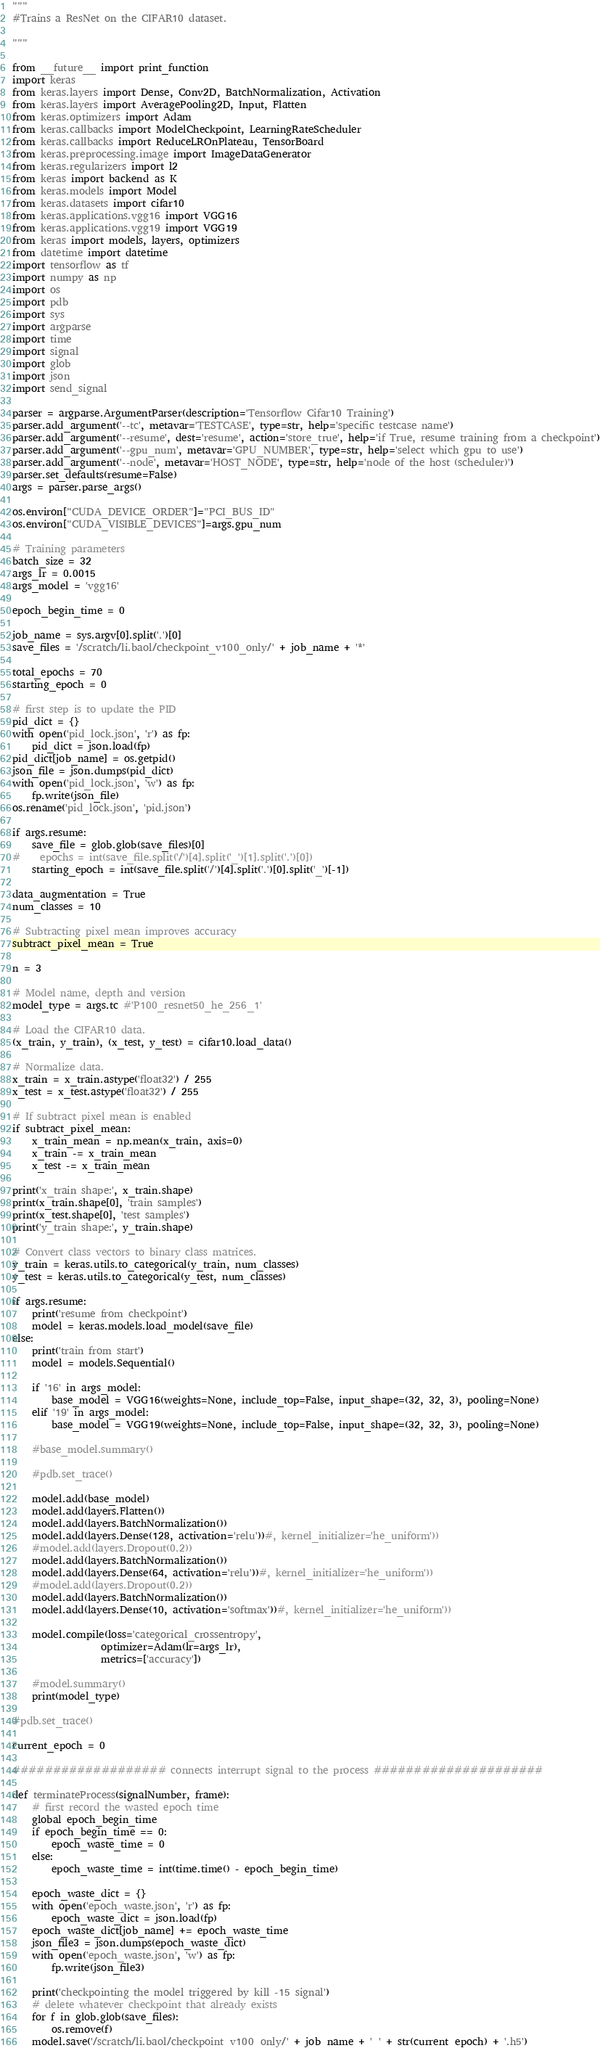<code> <loc_0><loc_0><loc_500><loc_500><_Python_>"""
#Trains a ResNet on the CIFAR10 dataset.

"""

from __future__ import print_function
import keras
from keras.layers import Dense, Conv2D, BatchNormalization, Activation
from keras.layers import AveragePooling2D, Input, Flatten
from keras.optimizers import Adam
from keras.callbacks import ModelCheckpoint, LearningRateScheduler
from keras.callbacks import ReduceLROnPlateau, TensorBoard
from keras.preprocessing.image import ImageDataGenerator
from keras.regularizers import l2
from keras import backend as K
from keras.models import Model
from keras.datasets import cifar10
from keras.applications.vgg16 import VGG16
from keras.applications.vgg19 import VGG19
from keras import models, layers, optimizers
from datetime import datetime
import tensorflow as tf
import numpy as np
import os
import pdb
import sys
import argparse
import time
import signal
import glob
import json
import send_signal

parser = argparse.ArgumentParser(description='Tensorflow Cifar10 Training')
parser.add_argument('--tc', metavar='TESTCASE', type=str, help='specific testcase name')
parser.add_argument('--resume', dest='resume', action='store_true', help='if True, resume training from a checkpoint')
parser.add_argument('--gpu_num', metavar='GPU_NUMBER', type=str, help='select which gpu to use')
parser.add_argument('--node', metavar='HOST_NODE', type=str, help='node of the host (scheduler)')
parser.set_defaults(resume=False)
args = parser.parse_args()

os.environ["CUDA_DEVICE_ORDER"]="PCI_BUS_ID"
os.environ["CUDA_VISIBLE_DEVICES"]=args.gpu_num

# Training parameters
batch_size = 32
args_lr = 0.0015
args_model = 'vgg16'

epoch_begin_time = 0

job_name = sys.argv[0].split('.')[0]
save_files = '/scratch/li.baol/checkpoint_v100_only/' + job_name + '*'

total_epochs = 70
starting_epoch = 0

# first step is to update the PID
pid_dict = {}
with open('pid_lock.json', 'r') as fp:
    pid_dict = json.load(fp)
pid_dict[job_name] = os.getpid()
json_file = json.dumps(pid_dict)
with open('pid_lock.json', 'w') as fp:
    fp.write(json_file) 
os.rename('pid_lock.json', 'pid.json')

if args.resume:
    save_file = glob.glob(save_files)[0]
#    epochs = int(save_file.split('/')[4].split('_')[1].split('.')[0])
    starting_epoch = int(save_file.split('/')[4].split('.')[0].split('_')[-1])

data_augmentation = True
num_classes = 10

# Subtracting pixel mean improves accuracy
subtract_pixel_mean = True

n = 3

# Model name, depth and version
model_type = args.tc #'P100_resnet50_he_256_1'

# Load the CIFAR10 data.
(x_train, y_train), (x_test, y_test) = cifar10.load_data()

# Normalize data.
x_train = x_train.astype('float32') / 255
x_test = x_test.astype('float32') / 255

# If subtract pixel mean is enabled
if subtract_pixel_mean:
    x_train_mean = np.mean(x_train, axis=0)
    x_train -= x_train_mean
    x_test -= x_train_mean

print('x_train shape:', x_train.shape)
print(x_train.shape[0], 'train samples')
print(x_test.shape[0], 'test samples')
print('y_train shape:', y_train.shape)

# Convert class vectors to binary class matrices.
y_train = keras.utils.to_categorical(y_train, num_classes)
y_test = keras.utils.to_categorical(y_test, num_classes)

if args.resume:
    print('resume from checkpoint')
    model = keras.models.load_model(save_file)
else:
    print('train from start')
    model = models.Sequential()
    
    if '16' in args_model:
        base_model = VGG16(weights=None, include_top=False, input_shape=(32, 32, 3), pooling=None)
    elif '19' in args_model:
        base_model = VGG19(weights=None, include_top=False, input_shape=(32, 32, 3), pooling=None)
    
    #base_model.summary()
    
    #pdb.set_trace()
    
    model.add(base_model)
    model.add(layers.Flatten())
    model.add(layers.BatchNormalization())
    model.add(layers.Dense(128, activation='relu'))#, kernel_initializer='he_uniform'))
    #model.add(layers.Dropout(0.2))
    model.add(layers.BatchNormalization())
    model.add(layers.Dense(64, activation='relu'))#, kernel_initializer='he_uniform'))
    #model.add(layers.Dropout(0.2))
    model.add(layers.BatchNormalization())
    model.add(layers.Dense(10, activation='softmax'))#, kernel_initializer='he_uniform'))
    
    model.compile(loss='categorical_crossentropy',
                  optimizer=Adam(lr=args_lr),
                  metrics=['accuracy'])
    
    #model.summary()
    print(model_type)

#pdb.set_trace()

current_epoch = 0

################### connects interrupt signal to the process #####################

def terminateProcess(signalNumber, frame):
    # first record the wasted epoch time
    global epoch_begin_time
    if epoch_begin_time == 0:
        epoch_waste_time = 0
    else:
        epoch_waste_time = int(time.time() - epoch_begin_time)

    epoch_waste_dict = {}
    with open('epoch_waste.json', 'r') as fp:
        epoch_waste_dict = json.load(fp)
    epoch_waste_dict[job_name] += epoch_waste_time
    json_file3 = json.dumps(epoch_waste_dict)
    with open('epoch_waste.json', 'w') as fp:
        fp.write(json_file3)

    print('checkpointing the model triggered by kill -15 signal')
    # delete whatever checkpoint that already exists
    for f in glob.glob(save_files):
        os.remove(f)
    model.save('/scratch/li.baol/checkpoint_v100_only/' + job_name + '_' + str(current_epoch) + '.h5')</code> 